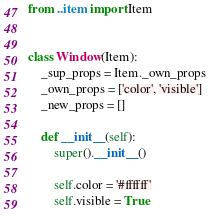<code> <loc_0><loc_0><loc_500><loc_500><_Python_>from ..item import Item


class Window(Item):
    _sup_props = Item._own_props
    _own_props = ['color', 'visible']
    _new_props = []
    
    def __init__(self):
        super().__init__()
        
        self.color = '#ffffff'
        self.visible = True
</code> 